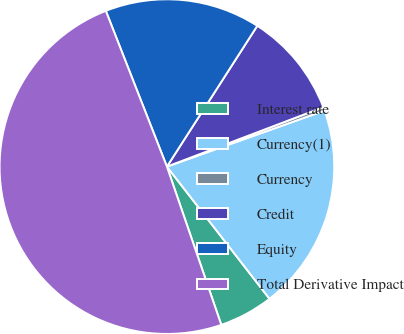Convert chart. <chart><loc_0><loc_0><loc_500><loc_500><pie_chart><fcel>Interest rate<fcel>Currency(1)<fcel>Currency<fcel>Credit<fcel>Equity<fcel>Total Derivative Impact<nl><fcel>5.24%<fcel>19.93%<fcel>0.34%<fcel>10.14%<fcel>15.03%<fcel>49.32%<nl></chart> 